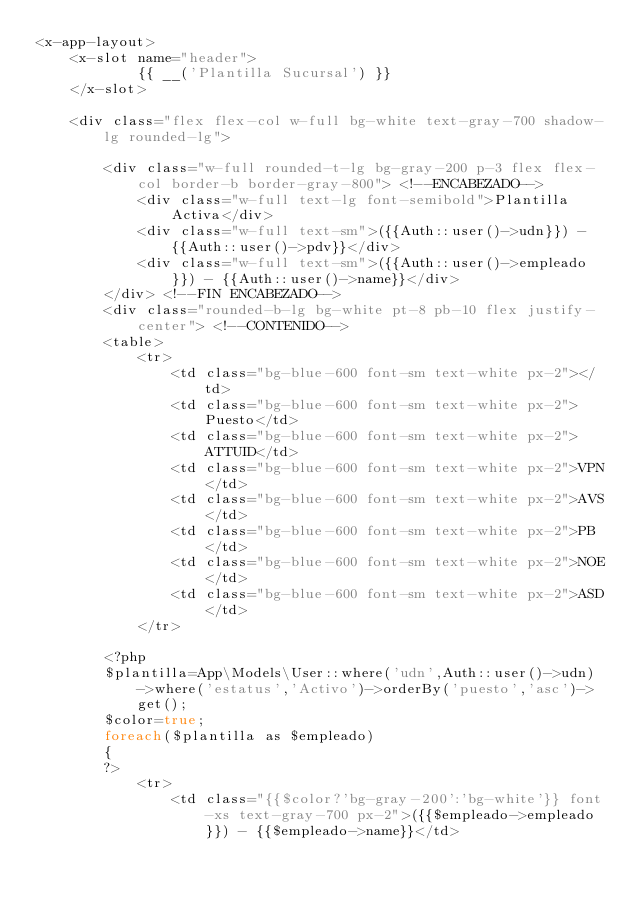Convert code to text. <code><loc_0><loc_0><loc_500><loc_500><_PHP_><x-app-layout>
    <x-slot name="header">
            {{ __('Plantilla Sucursal') }}
    </x-slot>

    <div class="flex flex-col w-full bg-white text-gray-700 shadow-lg rounded-lg">
        
        <div class="w-full rounded-t-lg bg-gray-200 p-3 flex flex-col border-b border-gray-800"> <!--ENCABEZADO-->
            <div class="w-full text-lg font-semibold">Plantilla Activa</div>
            <div class="w-full text-sm">({{Auth::user()->udn}}) - {{Auth::user()->pdv}}</div>
            <div class="w-full text-sm">({{Auth::user()->empleado}}) - {{Auth::user()->name}}</div>                        
        </div> <!--FIN ENCABEZADO-->
        <div class="rounded-b-lg bg-white pt-8 pb-10 flex justify-center"> <!--CONTENIDO-->
        <table>
            <tr>
                <td class="bg-blue-600 font-sm text-white px-2"></td>
                <td class="bg-blue-600 font-sm text-white px-2">Puesto</td>
                <td class="bg-blue-600 font-sm text-white px-2">ATTUID</td>
                <td class="bg-blue-600 font-sm text-white px-2">VPN</td>
                <td class="bg-blue-600 font-sm text-white px-2">AVS</td>
                <td class="bg-blue-600 font-sm text-white px-2">PB</td>
                <td class="bg-blue-600 font-sm text-white px-2">NOE</td>
                <td class="bg-blue-600 font-sm text-white px-2">ASD</td>
            </tr>    

        <?php
        $plantilla=App\Models\User::where('udn',Auth::user()->udn)->where('estatus','Activo')->orderBy('puesto','asc')->get();
        $color=true;
        foreach($plantilla as $empleado)
        {
        ?>
            <tr>
                <td class="{{$color?'bg-gray-200':'bg-white'}} font-xs text-gray-700 px-2">({{$empleado->empleado}}) - {{$empleado->name}}</td></code> 